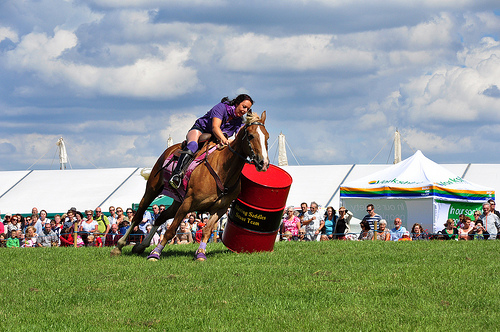<image>
Is there a woman on the horse? Yes. Looking at the image, I can see the woman is positioned on top of the horse, with the horse providing support. Is the horse under the woman? Yes. The horse is positioned underneath the woman, with the woman above it in the vertical space. 